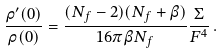Convert formula to latex. <formula><loc_0><loc_0><loc_500><loc_500>\frac { \rho ^ { \prime } ( 0 ) } { \rho ( 0 ) } = \frac { ( N _ { f } - 2 ) ( N _ { f } + \beta ) } { 1 6 \pi \beta N _ { f } } \frac { \Sigma } { F ^ { 4 } } \, .</formula> 